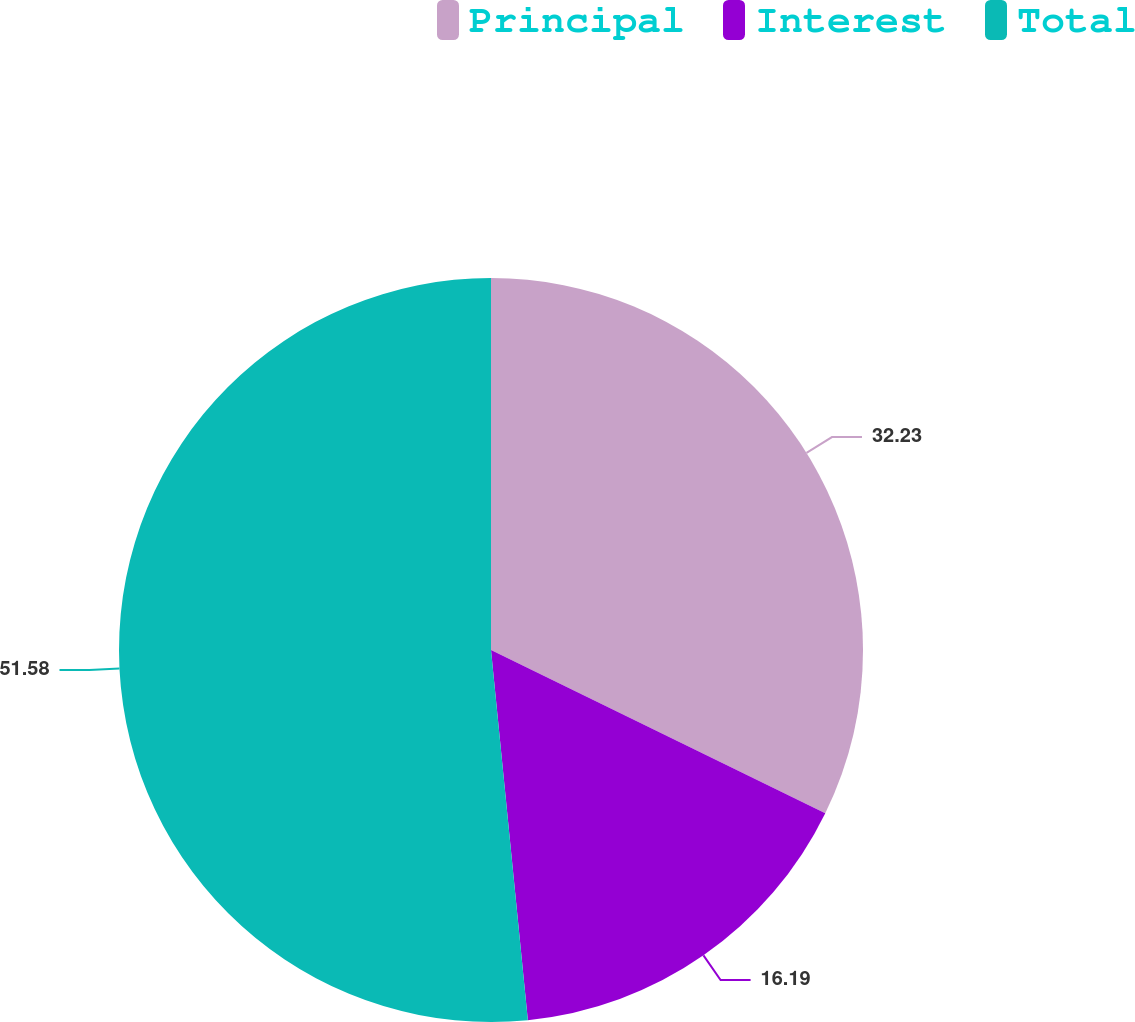Convert chart to OTSL. <chart><loc_0><loc_0><loc_500><loc_500><pie_chart><fcel>Principal<fcel>Interest<fcel>Total<nl><fcel>32.23%<fcel>16.19%<fcel>51.58%<nl></chart> 